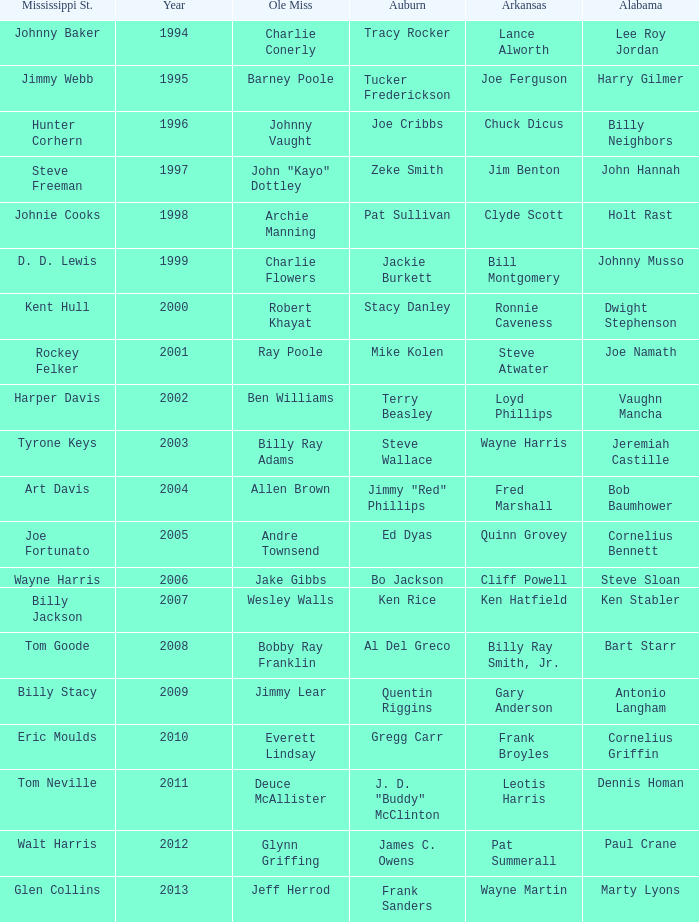Who was the player associated with Ole Miss in years after 2008 with a Mississippi St. name of Eric Moulds? Everett Lindsay. 